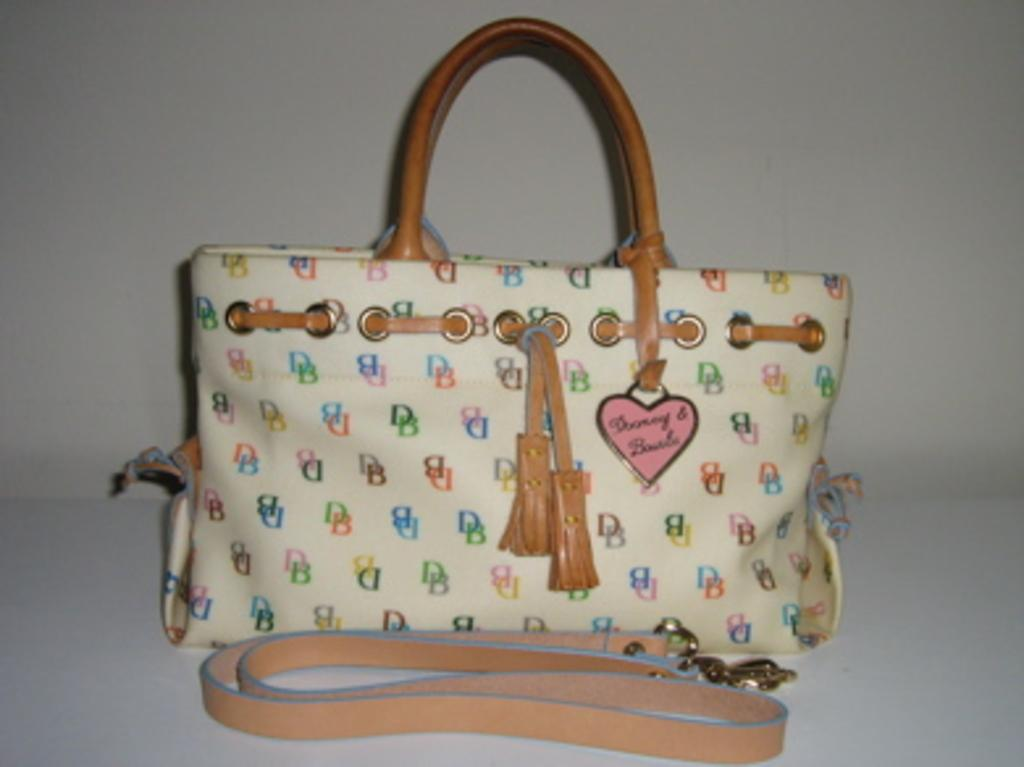What type of accessory is present in the image? There is a handbag in the image. What design element is featured on the handbag? The handbag has a heart symbol on it. How many goldfish are swimming in the handbag in the image? There are no goldfish present in the image; it features a handbag with a heart symbol on it. 